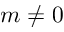<formula> <loc_0><loc_0><loc_500><loc_500>m \neq 0</formula> 